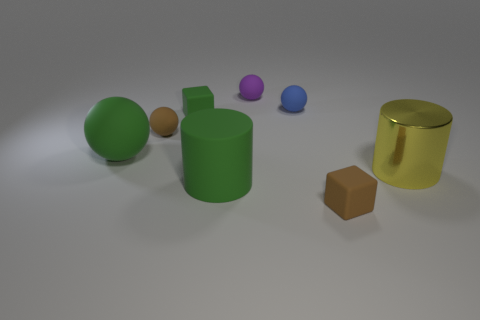Add 1 small brown rubber spheres. How many objects exist? 9 Subtract all blocks. How many objects are left? 6 Add 4 tiny blue rubber spheres. How many tiny blue rubber spheres exist? 5 Subtract 0 red cubes. How many objects are left? 8 Subtract all large balls. Subtract all large cyan rubber blocks. How many objects are left? 7 Add 2 purple matte things. How many purple matte things are left? 3 